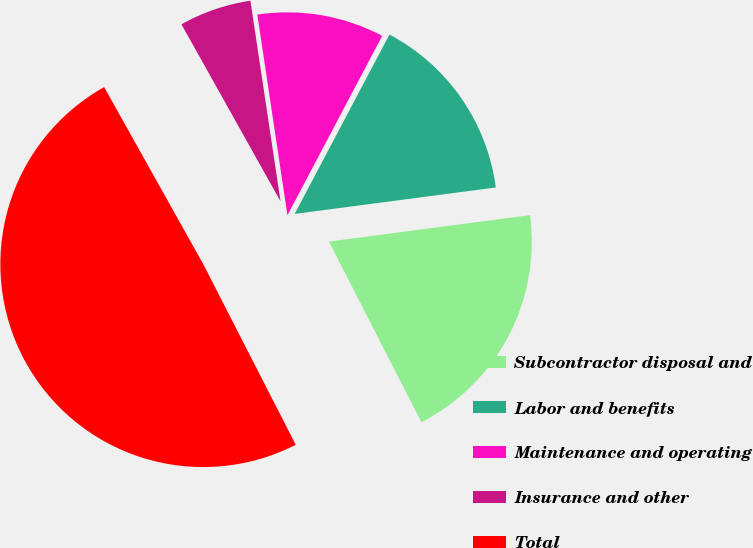Convert chart. <chart><loc_0><loc_0><loc_500><loc_500><pie_chart><fcel>Subcontractor disposal and<fcel>Labor and benefits<fcel>Maintenance and operating<fcel>Insurance and other<fcel>Total<nl><fcel>19.55%<fcel>15.18%<fcel>10.11%<fcel>5.75%<fcel>49.41%<nl></chart> 